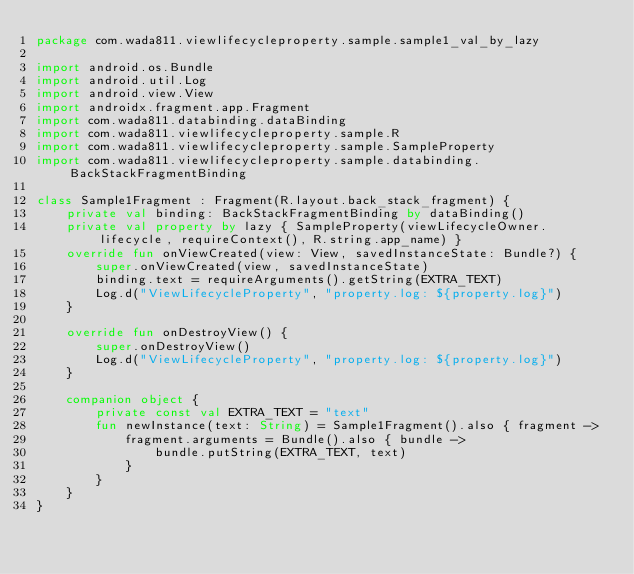<code> <loc_0><loc_0><loc_500><loc_500><_Kotlin_>package com.wada811.viewlifecycleproperty.sample.sample1_val_by_lazy

import android.os.Bundle
import android.util.Log
import android.view.View
import androidx.fragment.app.Fragment
import com.wada811.databinding.dataBinding
import com.wada811.viewlifecycleproperty.sample.R
import com.wada811.viewlifecycleproperty.sample.SampleProperty
import com.wada811.viewlifecycleproperty.sample.databinding.BackStackFragmentBinding

class Sample1Fragment : Fragment(R.layout.back_stack_fragment) {
    private val binding: BackStackFragmentBinding by dataBinding()
    private val property by lazy { SampleProperty(viewLifecycleOwner.lifecycle, requireContext(), R.string.app_name) }
    override fun onViewCreated(view: View, savedInstanceState: Bundle?) {
        super.onViewCreated(view, savedInstanceState)
        binding.text = requireArguments().getString(EXTRA_TEXT)
        Log.d("ViewLifecycleProperty", "property.log: ${property.log}")
    }

    override fun onDestroyView() {
        super.onDestroyView()
        Log.d("ViewLifecycleProperty", "property.log: ${property.log}")
    }

    companion object {
        private const val EXTRA_TEXT = "text"
        fun newInstance(text: String) = Sample1Fragment().also { fragment ->
            fragment.arguments = Bundle().also { bundle ->
                bundle.putString(EXTRA_TEXT, text)
            }
        }
    }
}
</code> 